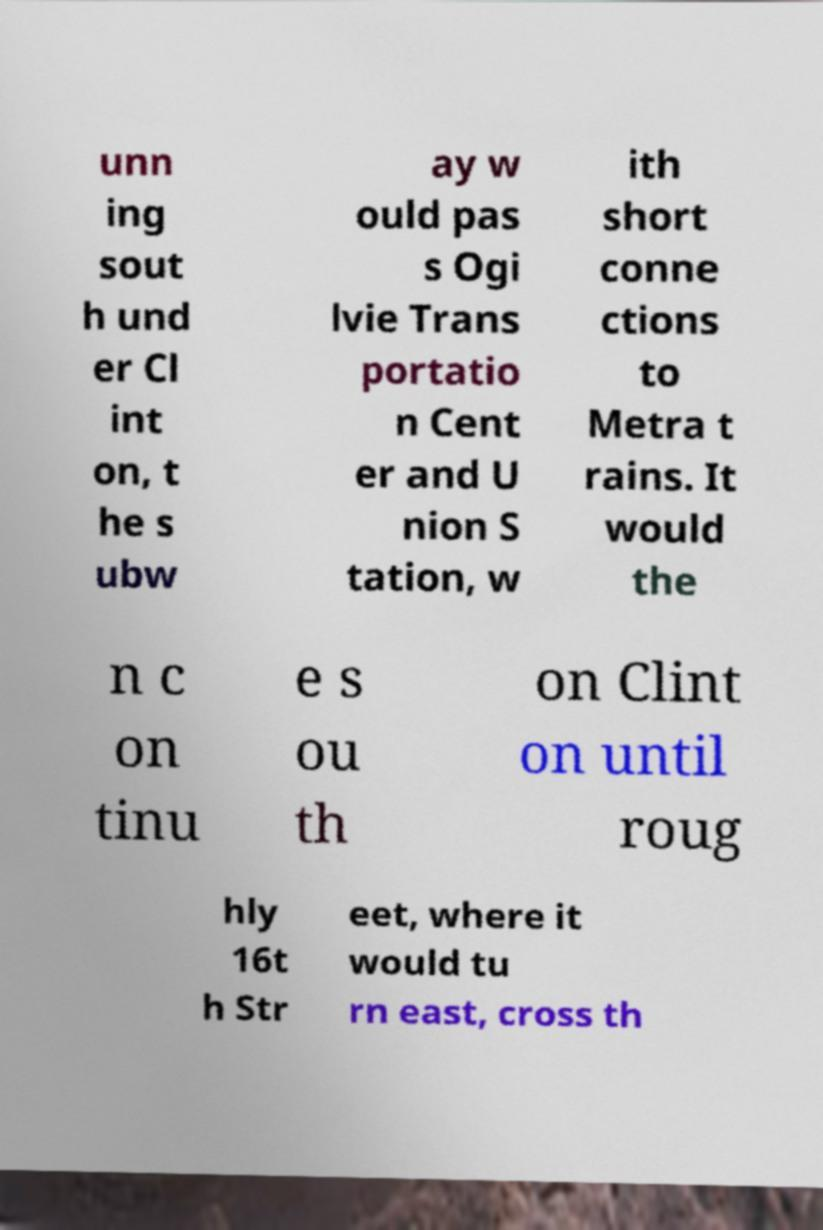Please identify and transcribe the text found in this image. unn ing sout h und er Cl int on, t he s ubw ay w ould pas s Ogi lvie Trans portatio n Cent er and U nion S tation, w ith short conne ctions to Metra t rains. It would the n c on tinu e s ou th on Clint on until roug hly 16t h Str eet, where it would tu rn east, cross th 